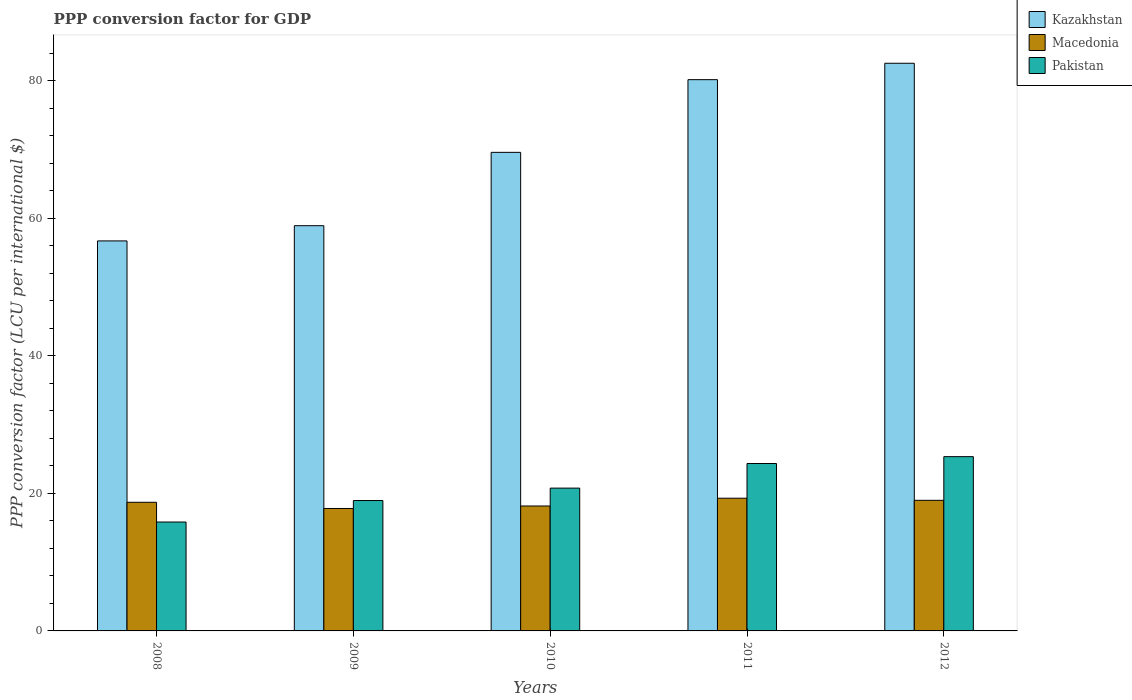How many different coloured bars are there?
Provide a short and direct response. 3. How many groups of bars are there?
Your answer should be very brief. 5. Are the number of bars per tick equal to the number of legend labels?
Offer a terse response. Yes. What is the PPP conversion factor for GDP in Macedonia in 2009?
Your answer should be compact. 17.81. Across all years, what is the maximum PPP conversion factor for GDP in Kazakhstan?
Your response must be concise. 82.56. Across all years, what is the minimum PPP conversion factor for GDP in Macedonia?
Make the answer very short. 17.81. In which year was the PPP conversion factor for GDP in Pakistan minimum?
Your answer should be very brief. 2008. What is the total PPP conversion factor for GDP in Macedonia in the graph?
Your answer should be very brief. 92.98. What is the difference between the PPP conversion factor for GDP in Macedonia in 2008 and that in 2011?
Give a very brief answer. -0.59. What is the difference between the PPP conversion factor for GDP in Kazakhstan in 2011 and the PPP conversion factor for GDP in Pakistan in 2009?
Ensure brevity in your answer.  61.21. What is the average PPP conversion factor for GDP in Kazakhstan per year?
Give a very brief answer. 69.59. In the year 2008, what is the difference between the PPP conversion factor for GDP in Kazakhstan and PPP conversion factor for GDP in Macedonia?
Make the answer very short. 38.01. What is the ratio of the PPP conversion factor for GDP in Kazakhstan in 2009 to that in 2010?
Offer a very short reply. 0.85. Is the difference between the PPP conversion factor for GDP in Kazakhstan in 2009 and 2012 greater than the difference between the PPP conversion factor for GDP in Macedonia in 2009 and 2012?
Make the answer very short. No. What is the difference between the highest and the second highest PPP conversion factor for GDP in Pakistan?
Provide a succinct answer. 1. What is the difference between the highest and the lowest PPP conversion factor for GDP in Kazakhstan?
Your response must be concise. 25.84. Is the sum of the PPP conversion factor for GDP in Macedonia in 2009 and 2011 greater than the maximum PPP conversion factor for GDP in Kazakhstan across all years?
Offer a very short reply. No. What does the 2nd bar from the left in 2012 represents?
Ensure brevity in your answer.  Macedonia. Is it the case that in every year, the sum of the PPP conversion factor for GDP in Pakistan and PPP conversion factor for GDP in Macedonia is greater than the PPP conversion factor for GDP in Kazakhstan?
Offer a very short reply. No. How many bars are there?
Ensure brevity in your answer.  15. How many years are there in the graph?
Your answer should be very brief. 5. Does the graph contain any zero values?
Give a very brief answer. No. Where does the legend appear in the graph?
Your response must be concise. Top right. How are the legend labels stacked?
Your answer should be very brief. Vertical. What is the title of the graph?
Offer a very short reply. PPP conversion factor for GDP. What is the label or title of the Y-axis?
Keep it short and to the point. PPP conversion factor (LCU per international $). What is the PPP conversion factor (LCU per international $) in Kazakhstan in 2008?
Your response must be concise. 56.72. What is the PPP conversion factor (LCU per international $) in Macedonia in 2008?
Offer a terse response. 18.71. What is the PPP conversion factor (LCU per international $) of Pakistan in 2008?
Your response must be concise. 15.84. What is the PPP conversion factor (LCU per international $) in Kazakhstan in 2009?
Keep it short and to the point. 58.93. What is the PPP conversion factor (LCU per international $) in Macedonia in 2009?
Provide a succinct answer. 17.81. What is the PPP conversion factor (LCU per international $) of Pakistan in 2009?
Your answer should be compact. 18.96. What is the PPP conversion factor (LCU per international $) of Kazakhstan in 2010?
Provide a succinct answer. 69.6. What is the PPP conversion factor (LCU per international $) in Macedonia in 2010?
Give a very brief answer. 18.17. What is the PPP conversion factor (LCU per international $) in Pakistan in 2010?
Your answer should be compact. 20.77. What is the PPP conversion factor (LCU per international $) of Kazakhstan in 2011?
Make the answer very short. 80.17. What is the PPP conversion factor (LCU per international $) of Macedonia in 2011?
Give a very brief answer. 19.3. What is the PPP conversion factor (LCU per international $) of Pakistan in 2011?
Make the answer very short. 24.35. What is the PPP conversion factor (LCU per international $) in Kazakhstan in 2012?
Offer a terse response. 82.56. What is the PPP conversion factor (LCU per international $) of Macedonia in 2012?
Offer a terse response. 18.99. What is the PPP conversion factor (LCU per international $) of Pakistan in 2012?
Give a very brief answer. 25.34. Across all years, what is the maximum PPP conversion factor (LCU per international $) in Kazakhstan?
Offer a terse response. 82.56. Across all years, what is the maximum PPP conversion factor (LCU per international $) of Macedonia?
Your answer should be very brief. 19.3. Across all years, what is the maximum PPP conversion factor (LCU per international $) in Pakistan?
Give a very brief answer. 25.34. Across all years, what is the minimum PPP conversion factor (LCU per international $) in Kazakhstan?
Provide a succinct answer. 56.72. Across all years, what is the minimum PPP conversion factor (LCU per international $) in Macedonia?
Your answer should be very brief. 17.81. Across all years, what is the minimum PPP conversion factor (LCU per international $) of Pakistan?
Keep it short and to the point. 15.84. What is the total PPP conversion factor (LCU per international $) in Kazakhstan in the graph?
Give a very brief answer. 347.98. What is the total PPP conversion factor (LCU per international $) in Macedonia in the graph?
Offer a terse response. 92.98. What is the total PPP conversion factor (LCU per international $) of Pakistan in the graph?
Your answer should be compact. 105.26. What is the difference between the PPP conversion factor (LCU per international $) in Kazakhstan in 2008 and that in 2009?
Provide a succinct answer. -2.21. What is the difference between the PPP conversion factor (LCU per international $) in Macedonia in 2008 and that in 2009?
Offer a terse response. 0.9. What is the difference between the PPP conversion factor (LCU per international $) in Pakistan in 2008 and that in 2009?
Your answer should be compact. -3.13. What is the difference between the PPP conversion factor (LCU per international $) of Kazakhstan in 2008 and that in 2010?
Keep it short and to the point. -12.88. What is the difference between the PPP conversion factor (LCU per international $) in Macedonia in 2008 and that in 2010?
Provide a succinct answer. 0.54. What is the difference between the PPP conversion factor (LCU per international $) of Pakistan in 2008 and that in 2010?
Your answer should be very brief. -4.93. What is the difference between the PPP conversion factor (LCU per international $) of Kazakhstan in 2008 and that in 2011?
Provide a short and direct response. -23.45. What is the difference between the PPP conversion factor (LCU per international $) in Macedonia in 2008 and that in 2011?
Your response must be concise. -0.59. What is the difference between the PPP conversion factor (LCU per international $) in Pakistan in 2008 and that in 2011?
Keep it short and to the point. -8.51. What is the difference between the PPP conversion factor (LCU per international $) in Kazakhstan in 2008 and that in 2012?
Your answer should be compact. -25.84. What is the difference between the PPP conversion factor (LCU per international $) of Macedonia in 2008 and that in 2012?
Offer a very short reply. -0.29. What is the difference between the PPP conversion factor (LCU per international $) in Pakistan in 2008 and that in 2012?
Make the answer very short. -9.51. What is the difference between the PPP conversion factor (LCU per international $) in Kazakhstan in 2009 and that in 2010?
Give a very brief answer. -10.67. What is the difference between the PPP conversion factor (LCU per international $) in Macedonia in 2009 and that in 2010?
Offer a terse response. -0.36. What is the difference between the PPP conversion factor (LCU per international $) in Pakistan in 2009 and that in 2010?
Offer a terse response. -1.8. What is the difference between the PPP conversion factor (LCU per international $) of Kazakhstan in 2009 and that in 2011?
Your answer should be very brief. -21.24. What is the difference between the PPP conversion factor (LCU per international $) of Macedonia in 2009 and that in 2011?
Give a very brief answer. -1.49. What is the difference between the PPP conversion factor (LCU per international $) in Pakistan in 2009 and that in 2011?
Your response must be concise. -5.38. What is the difference between the PPP conversion factor (LCU per international $) in Kazakhstan in 2009 and that in 2012?
Ensure brevity in your answer.  -23.62. What is the difference between the PPP conversion factor (LCU per international $) in Macedonia in 2009 and that in 2012?
Give a very brief answer. -1.19. What is the difference between the PPP conversion factor (LCU per international $) in Pakistan in 2009 and that in 2012?
Provide a short and direct response. -6.38. What is the difference between the PPP conversion factor (LCU per international $) in Kazakhstan in 2010 and that in 2011?
Your answer should be very brief. -10.57. What is the difference between the PPP conversion factor (LCU per international $) of Macedonia in 2010 and that in 2011?
Provide a short and direct response. -1.13. What is the difference between the PPP conversion factor (LCU per international $) of Pakistan in 2010 and that in 2011?
Your response must be concise. -3.58. What is the difference between the PPP conversion factor (LCU per international $) in Kazakhstan in 2010 and that in 2012?
Your response must be concise. -12.96. What is the difference between the PPP conversion factor (LCU per international $) in Macedonia in 2010 and that in 2012?
Ensure brevity in your answer.  -0.83. What is the difference between the PPP conversion factor (LCU per international $) of Pakistan in 2010 and that in 2012?
Offer a very short reply. -4.58. What is the difference between the PPP conversion factor (LCU per international $) in Kazakhstan in 2011 and that in 2012?
Your response must be concise. -2.39. What is the difference between the PPP conversion factor (LCU per international $) in Macedonia in 2011 and that in 2012?
Ensure brevity in your answer.  0.31. What is the difference between the PPP conversion factor (LCU per international $) of Pakistan in 2011 and that in 2012?
Your answer should be compact. -1. What is the difference between the PPP conversion factor (LCU per international $) of Kazakhstan in 2008 and the PPP conversion factor (LCU per international $) of Macedonia in 2009?
Your answer should be compact. 38.91. What is the difference between the PPP conversion factor (LCU per international $) of Kazakhstan in 2008 and the PPP conversion factor (LCU per international $) of Pakistan in 2009?
Give a very brief answer. 37.75. What is the difference between the PPP conversion factor (LCU per international $) of Macedonia in 2008 and the PPP conversion factor (LCU per international $) of Pakistan in 2009?
Keep it short and to the point. -0.26. What is the difference between the PPP conversion factor (LCU per international $) of Kazakhstan in 2008 and the PPP conversion factor (LCU per international $) of Macedonia in 2010?
Your answer should be very brief. 38.55. What is the difference between the PPP conversion factor (LCU per international $) of Kazakhstan in 2008 and the PPP conversion factor (LCU per international $) of Pakistan in 2010?
Offer a very short reply. 35.95. What is the difference between the PPP conversion factor (LCU per international $) in Macedonia in 2008 and the PPP conversion factor (LCU per international $) in Pakistan in 2010?
Give a very brief answer. -2.06. What is the difference between the PPP conversion factor (LCU per international $) of Kazakhstan in 2008 and the PPP conversion factor (LCU per international $) of Macedonia in 2011?
Keep it short and to the point. 37.42. What is the difference between the PPP conversion factor (LCU per international $) of Kazakhstan in 2008 and the PPP conversion factor (LCU per international $) of Pakistan in 2011?
Provide a short and direct response. 32.37. What is the difference between the PPP conversion factor (LCU per international $) in Macedonia in 2008 and the PPP conversion factor (LCU per international $) in Pakistan in 2011?
Offer a terse response. -5.64. What is the difference between the PPP conversion factor (LCU per international $) of Kazakhstan in 2008 and the PPP conversion factor (LCU per international $) of Macedonia in 2012?
Provide a short and direct response. 37.72. What is the difference between the PPP conversion factor (LCU per international $) of Kazakhstan in 2008 and the PPP conversion factor (LCU per international $) of Pakistan in 2012?
Provide a succinct answer. 31.37. What is the difference between the PPP conversion factor (LCU per international $) of Macedonia in 2008 and the PPP conversion factor (LCU per international $) of Pakistan in 2012?
Keep it short and to the point. -6.64. What is the difference between the PPP conversion factor (LCU per international $) in Kazakhstan in 2009 and the PPP conversion factor (LCU per international $) in Macedonia in 2010?
Offer a very short reply. 40.76. What is the difference between the PPP conversion factor (LCU per international $) in Kazakhstan in 2009 and the PPP conversion factor (LCU per international $) in Pakistan in 2010?
Your answer should be very brief. 38.16. What is the difference between the PPP conversion factor (LCU per international $) of Macedonia in 2009 and the PPP conversion factor (LCU per international $) of Pakistan in 2010?
Keep it short and to the point. -2.96. What is the difference between the PPP conversion factor (LCU per international $) in Kazakhstan in 2009 and the PPP conversion factor (LCU per international $) in Macedonia in 2011?
Offer a very short reply. 39.63. What is the difference between the PPP conversion factor (LCU per international $) of Kazakhstan in 2009 and the PPP conversion factor (LCU per international $) of Pakistan in 2011?
Offer a very short reply. 34.59. What is the difference between the PPP conversion factor (LCU per international $) of Macedonia in 2009 and the PPP conversion factor (LCU per international $) of Pakistan in 2011?
Keep it short and to the point. -6.54. What is the difference between the PPP conversion factor (LCU per international $) in Kazakhstan in 2009 and the PPP conversion factor (LCU per international $) in Macedonia in 2012?
Make the answer very short. 39.94. What is the difference between the PPP conversion factor (LCU per international $) of Kazakhstan in 2009 and the PPP conversion factor (LCU per international $) of Pakistan in 2012?
Offer a terse response. 33.59. What is the difference between the PPP conversion factor (LCU per international $) in Macedonia in 2009 and the PPP conversion factor (LCU per international $) in Pakistan in 2012?
Offer a terse response. -7.54. What is the difference between the PPP conversion factor (LCU per international $) of Kazakhstan in 2010 and the PPP conversion factor (LCU per international $) of Macedonia in 2011?
Your answer should be very brief. 50.3. What is the difference between the PPP conversion factor (LCU per international $) of Kazakhstan in 2010 and the PPP conversion factor (LCU per international $) of Pakistan in 2011?
Keep it short and to the point. 45.25. What is the difference between the PPP conversion factor (LCU per international $) in Macedonia in 2010 and the PPP conversion factor (LCU per international $) in Pakistan in 2011?
Give a very brief answer. -6.18. What is the difference between the PPP conversion factor (LCU per international $) of Kazakhstan in 2010 and the PPP conversion factor (LCU per international $) of Macedonia in 2012?
Your response must be concise. 50.6. What is the difference between the PPP conversion factor (LCU per international $) of Kazakhstan in 2010 and the PPP conversion factor (LCU per international $) of Pakistan in 2012?
Ensure brevity in your answer.  44.25. What is the difference between the PPP conversion factor (LCU per international $) of Macedonia in 2010 and the PPP conversion factor (LCU per international $) of Pakistan in 2012?
Your response must be concise. -7.18. What is the difference between the PPP conversion factor (LCU per international $) in Kazakhstan in 2011 and the PPP conversion factor (LCU per international $) in Macedonia in 2012?
Give a very brief answer. 61.18. What is the difference between the PPP conversion factor (LCU per international $) in Kazakhstan in 2011 and the PPP conversion factor (LCU per international $) in Pakistan in 2012?
Your response must be concise. 54.83. What is the difference between the PPP conversion factor (LCU per international $) of Macedonia in 2011 and the PPP conversion factor (LCU per international $) of Pakistan in 2012?
Provide a succinct answer. -6.04. What is the average PPP conversion factor (LCU per international $) in Kazakhstan per year?
Provide a succinct answer. 69.59. What is the average PPP conversion factor (LCU per international $) of Macedonia per year?
Offer a terse response. 18.6. What is the average PPP conversion factor (LCU per international $) of Pakistan per year?
Offer a terse response. 21.05. In the year 2008, what is the difference between the PPP conversion factor (LCU per international $) of Kazakhstan and PPP conversion factor (LCU per international $) of Macedonia?
Ensure brevity in your answer.  38.01. In the year 2008, what is the difference between the PPP conversion factor (LCU per international $) in Kazakhstan and PPP conversion factor (LCU per international $) in Pakistan?
Offer a very short reply. 40.88. In the year 2008, what is the difference between the PPP conversion factor (LCU per international $) of Macedonia and PPP conversion factor (LCU per international $) of Pakistan?
Offer a very short reply. 2.87. In the year 2009, what is the difference between the PPP conversion factor (LCU per international $) of Kazakhstan and PPP conversion factor (LCU per international $) of Macedonia?
Your answer should be compact. 41.12. In the year 2009, what is the difference between the PPP conversion factor (LCU per international $) in Kazakhstan and PPP conversion factor (LCU per international $) in Pakistan?
Offer a terse response. 39.97. In the year 2009, what is the difference between the PPP conversion factor (LCU per international $) in Macedonia and PPP conversion factor (LCU per international $) in Pakistan?
Offer a very short reply. -1.16. In the year 2010, what is the difference between the PPP conversion factor (LCU per international $) of Kazakhstan and PPP conversion factor (LCU per international $) of Macedonia?
Offer a very short reply. 51.43. In the year 2010, what is the difference between the PPP conversion factor (LCU per international $) of Kazakhstan and PPP conversion factor (LCU per international $) of Pakistan?
Provide a short and direct response. 48.83. In the year 2010, what is the difference between the PPP conversion factor (LCU per international $) of Macedonia and PPP conversion factor (LCU per international $) of Pakistan?
Offer a terse response. -2.6. In the year 2011, what is the difference between the PPP conversion factor (LCU per international $) in Kazakhstan and PPP conversion factor (LCU per international $) in Macedonia?
Make the answer very short. 60.87. In the year 2011, what is the difference between the PPP conversion factor (LCU per international $) of Kazakhstan and PPP conversion factor (LCU per international $) of Pakistan?
Offer a terse response. 55.82. In the year 2011, what is the difference between the PPP conversion factor (LCU per international $) of Macedonia and PPP conversion factor (LCU per international $) of Pakistan?
Offer a terse response. -5.04. In the year 2012, what is the difference between the PPP conversion factor (LCU per international $) in Kazakhstan and PPP conversion factor (LCU per international $) in Macedonia?
Keep it short and to the point. 63.56. In the year 2012, what is the difference between the PPP conversion factor (LCU per international $) of Kazakhstan and PPP conversion factor (LCU per international $) of Pakistan?
Keep it short and to the point. 57.21. In the year 2012, what is the difference between the PPP conversion factor (LCU per international $) of Macedonia and PPP conversion factor (LCU per international $) of Pakistan?
Offer a terse response. -6.35. What is the ratio of the PPP conversion factor (LCU per international $) of Kazakhstan in 2008 to that in 2009?
Keep it short and to the point. 0.96. What is the ratio of the PPP conversion factor (LCU per international $) of Macedonia in 2008 to that in 2009?
Your response must be concise. 1.05. What is the ratio of the PPP conversion factor (LCU per international $) in Pakistan in 2008 to that in 2009?
Provide a succinct answer. 0.83. What is the ratio of the PPP conversion factor (LCU per international $) in Kazakhstan in 2008 to that in 2010?
Offer a very short reply. 0.81. What is the ratio of the PPP conversion factor (LCU per international $) in Macedonia in 2008 to that in 2010?
Provide a short and direct response. 1.03. What is the ratio of the PPP conversion factor (LCU per international $) of Pakistan in 2008 to that in 2010?
Make the answer very short. 0.76. What is the ratio of the PPP conversion factor (LCU per international $) of Kazakhstan in 2008 to that in 2011?
Your response must be concise. 0.71. What is the ratio of the PPP conversion factor (LCU per international $) in Macedonia in 2008 to that in 2011?
Keep it short and to the point. 0.97. What is the ratio of the PPP conversion factor (LCU per international $) in Pakistan in 2008 to that in 2011?
Keep it short and to the point. 0.65. What is the ratio of the PPP conversion factor (LCU per international $) of Kazakhstan in 2008 to that in 2012?
Offer a terse response. 0.69. What is the ratio of the PPP conversion factor (LCU per international $) in Macedonia in 2008 to that in 2012?
Make the answer very short. 0.98. What is the ratio of the PPP conversion factor (LCU per international $) in Pakistan in 2008 to that in 2012?
Offer a very short reply. 0.62. What is the ratio of the PPP conversion factor (LCU per international $) in Kazakhstan in 2009 to that in 2010?
Make the answer very short. 0.85. What is the ratio of the PPP conversion factor (LCU per international $) in Macedonia in 2009 to that in 2010?
Your answer should be very brief. 0.98. What is the ratio of the PPP conversion factor (LCU per international $) of Pakistan in 2009 to that in 2010?
Provide a short and direct response. 0.91. What is the ratio of the PPP conversion factor (LCU per international $) of Kazakhstan in 2009 to that in 2011?
Ensure brevity in your answer.  0.74. What is the ratio of the PPP conversion factor (LCU per international $) in Macedonia in 2009 to that in 2011?
Provide a succinct answer. 0.92. What is the ratio of the PPP conversion factor (LCU per international $) of Pakistan in 2009 to that in 2011?
Provide a short and direct response. 0.78. What is the ratio of the PPP conversion factor (LCU per international $) of Kazakhstan in 2009 to that in 2012?
Offer a terse response. 0.71. What is the ratio of the PPP conversion factor (LCU per international $) of Pakistan in 2009 to that in 2012?
Your response must be concise. 0.75. What is the ratio of the PPP conversion factor (LCU per international $) of Kazakhstan in 2010 to that in 2011?
Offer a terse response. 0.87. What is the ratio of the PPP conversion factor (LCU per international $) in Macedonia in 2010 to that in 2011?
Offer a terse response. 0.94. What is the ratio of the PPP conversion factor (LCU per international $) in Pakistan in 2010 to that in 2011?
Give a very brief answer. 0.85. What is the ratio of the PPP conversion factor (LCU per international $) in Kazakhstan in 2010 to that in 2012?
Your answer should be very brief. 0.84. What is the ratio of the PPP conversion factor (LCU per international $) in Macedonia in 2010 to that in 2012?
Ensure brevity in your answer.  0.96. What is the ratio of the PPP conversion factor (LCU per international $) in Pakistan in 2010 to that in 2012?
Your answer should be very brief. 0.82. What is the ratio of the PPP conversion factor (LCU per international $) of Kazakhstan in 2011 to that in 2012?
Give a very brief answer. 0.97. What is the ratio of the PPP conversion factor (LCU per international $) in Macedonia in 2011 to that in 2012?
Keep it short and to the point. 1.02. What is the ratio of the PPP conversion factor (LCU per international $) of Pakistan in 2011 to that in 2012?
Give a very brief answer. 0.96. What is the difference between the highest and the second highest PPP conversion factor (LCU per international $) in Kazakhstan?
Provide a succinct answer. 2.39. What is the difference between the highest and the second highest PPP conversion factor (LCU per international $) of Macedonia?
Your answer should be compact. 0.31. What is the difference between the highest and the lowest PPP conversion factor (LCU per international $) in Kazakhstan?
Provide a succinct answer. 25.84. What is the difference between the highest and the lowest PPP conversion factor (LCU per international $) in Macedonia?
Make the answer very short. 1.49. What is the difference between the highest and the lowest PPP conversion factor (LCU per international $) of Pakistan?
Provide a succinct answer. 9.51. 